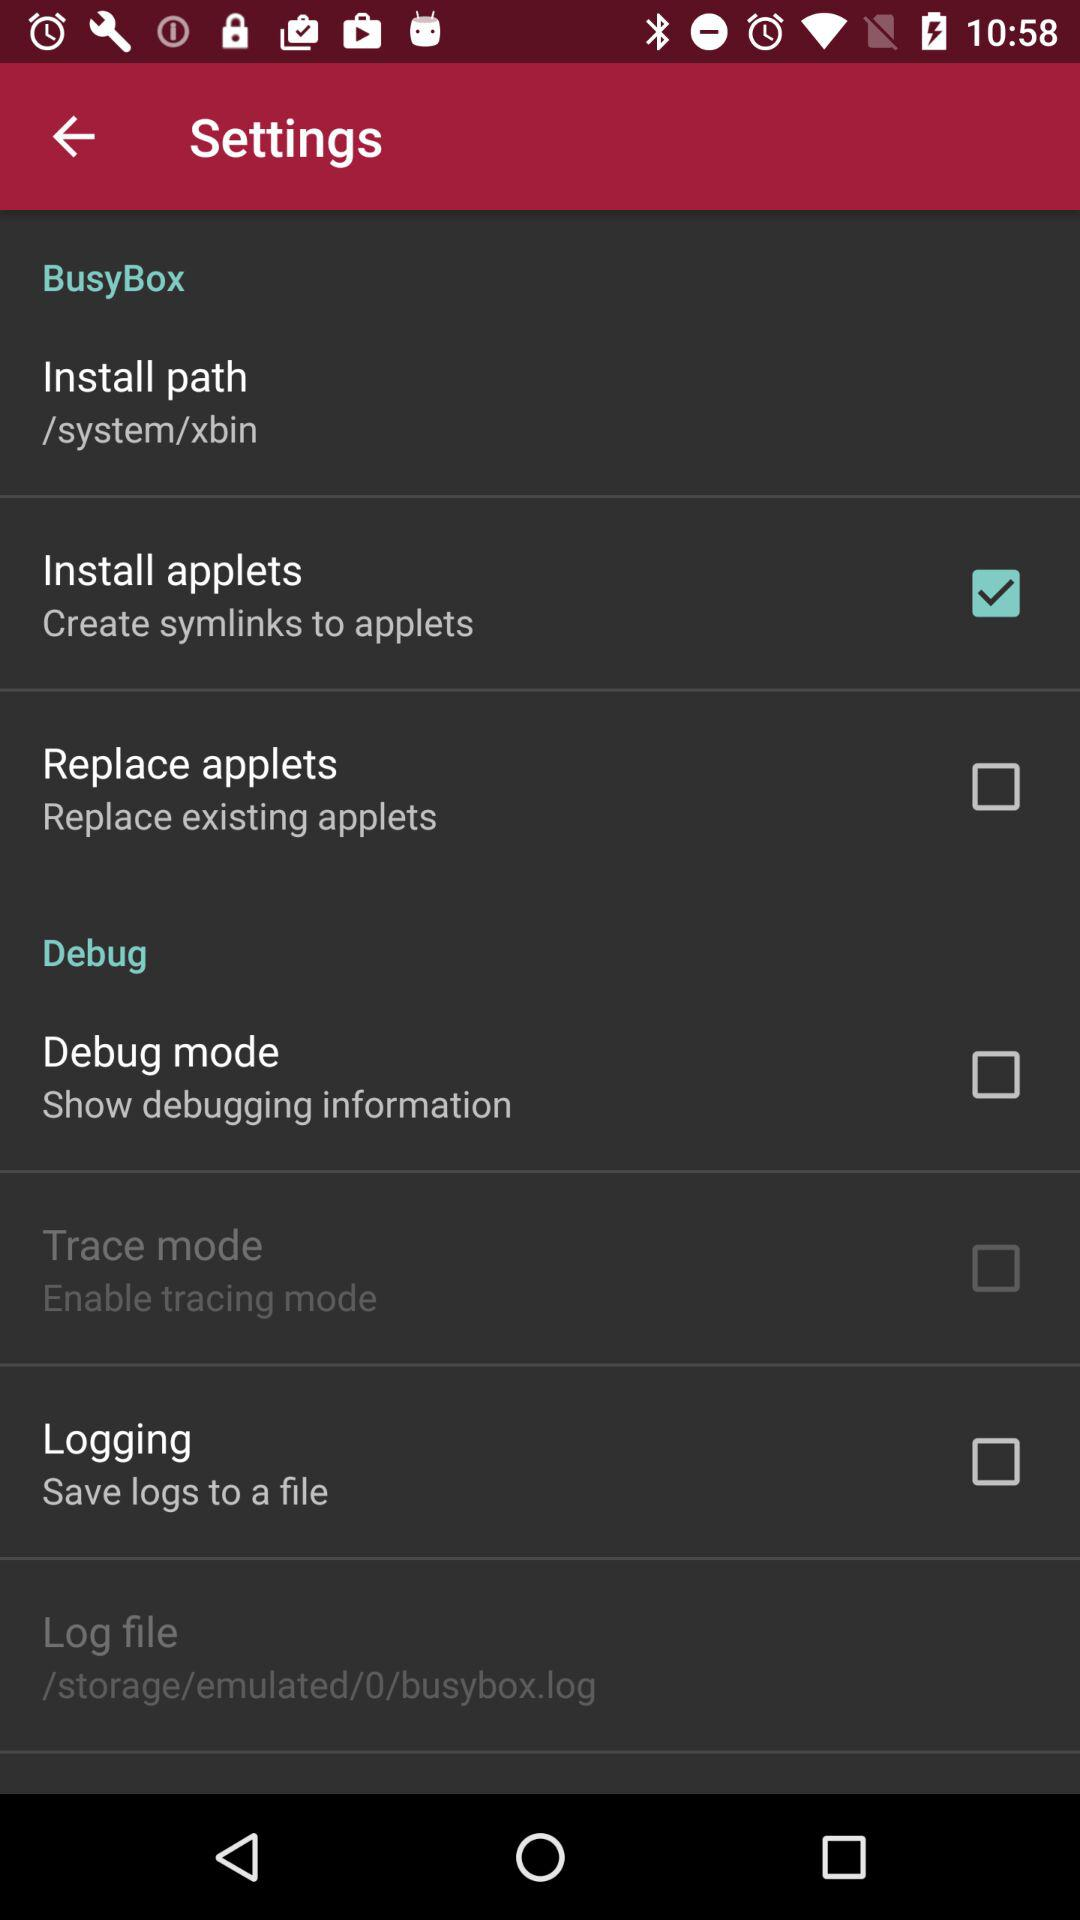How many items are in the Debug section?
Answer the question using a single word or phrase. 4 